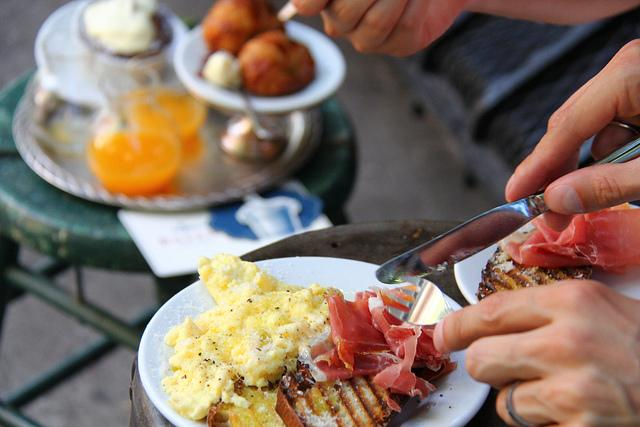What kind of fish is consumed on the side of the breakfast? Please explain your reasoning. salmon. The fish is lox. 